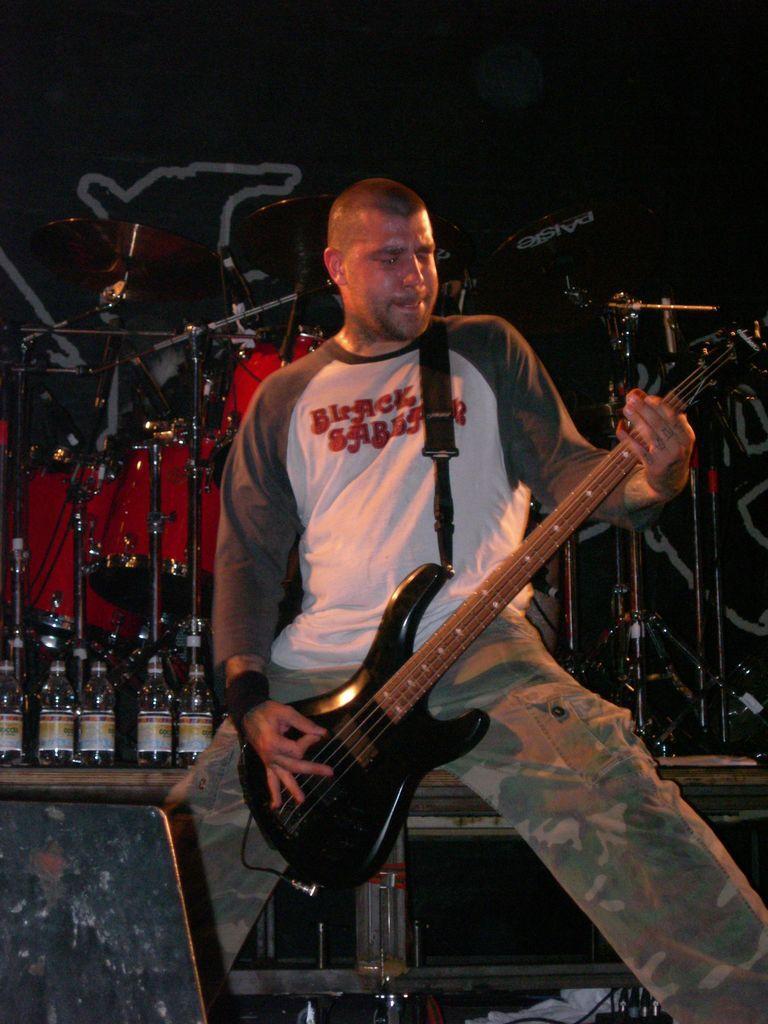How would you summarize this image in a sentence or two? In this image there is a man standing on the stage and playing guitar behind him there are so many musical instruments. 